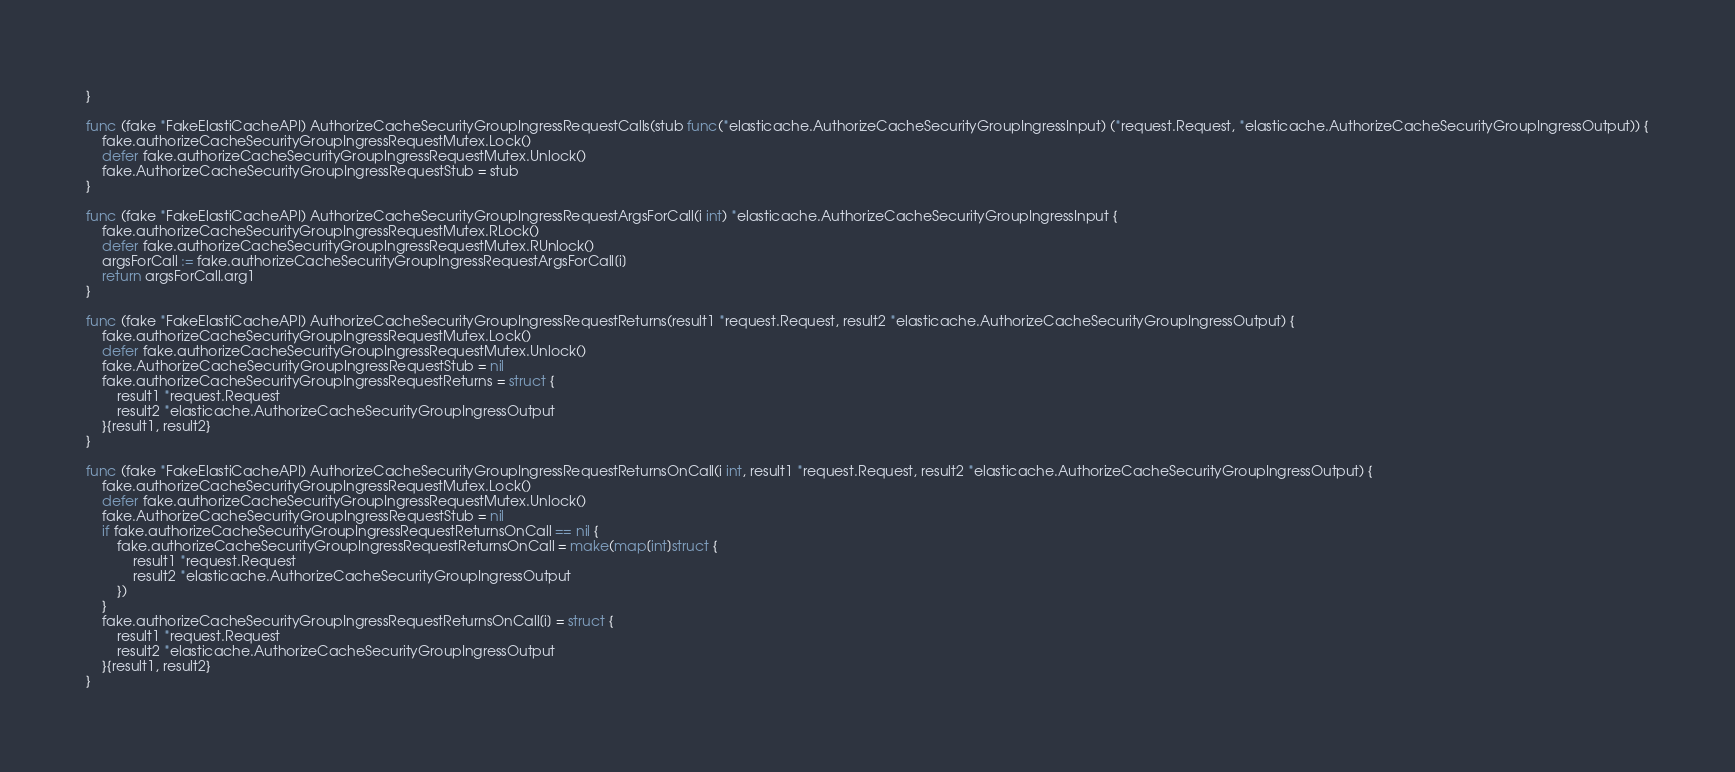<code> <loc_0><loc_0><loc_500><loc_500><_Go_>}

func (fake *FakeElastiCacheAPI) AuthorizeCacheSecurityGroupIngressRequestCalls(stub func(*elasticache.AuthorizeCacheSecurityGroupIngressInput) (*request.Request, *elasticache.AuthorizeCacheSecurityGroupIngressOutput)) {
	fake.authorizeCacheSecurityGroupIngressRequestMutex.Lock()
	defer fake.authorizeCacheSecurityGroupIngressRequestMutex.Unlock()
	fake.AuthorizeCacheSecurityGroupIngressRequestStub = stub
}

func (fake *FakeElastiCacheAPI) AuthorizeCacheSecurityGroupIngressRequestArgsForCall(i int) *elasticache.AuthorizeCacheSecurityGroupIngressInput {
	fake.authorizeCacheSecurityGroupIngressRequestMutex.RLock()
	defer fake.authorizeCacheSecurityGroupIngressRequestMutex.RUnlock()
	argsForCall := fake.authorizeCacheSecurityGroupIngressRequestArgsForCall[i]
	return argsForCall.arg1
}

func (fake *FakeElastiCacheAPI) AuthorizeCacheSecurityGroupIngressRequestReturns(result1 *request.Request, result2 *elasticache.AuthorizeCacheSecurityGroupIngressOutput) {
	fake.authorizeCacheSecurityGroupIngressRequestMutex.Lock()
	defer fake.authorizeCacheSecurityGroupIngressRequestMutex.Unlock()
	fake.AuthorizeCacheSecurityGroupIngressRequestStub = nil
	fake.authorizeCacheSecurityGroupIngressRequestReturns = struct {
		result1 *request.Request
		result2 *elasticache.AuthorizeCacheSecurityGroupIngressOutput
	}{result1, result2}
}

func (fake *FakeElastiCacheAPI) AuthorizeCacheSecurityGroupIngressRequestReturnsOnCall(i int, result1 *request.Request, result2 *elasticache.AuthorizeCacheSecurityGroupIngressOutput) {
	fake.authorizeCacheSecurityGroupIngressRequestMutex.Lock()
	defer fake.authorizeCacheSecurityGroupIngressRequestMutex.Unlock()
	fake.AuthorizeCacheSecurityGroupIngressRequestStub = nil
	if fake.authorizeCacheSecurityGroupIngressRequestReturnsOnCall == nil {
		fake.authorizeCacheSecurityGroupIngressRequestReturnsOnCall = make(map[int]struct {
			result1 *request.Request
			result2 *elasticache.AuthorizeCacheSecurityGroupIngressOutput
		})
	}
	fake.authorizeCacheSecurityGroupIngressRequestReturnsOnCall[i] = struct {
		result1 *request.Request
		result2 *elasticache.AuthorizeCacheSecurityGroupIngressOutput
	}{result1, result2}
}
</code> 